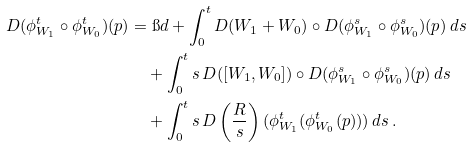<formula> <loc_0><loc_0><loc_500><loc_500>D ( \phi ^ { t } _ { W _ { 1 } } \circ \phi ^ { t } _ { W _ { 0 } } ) ( p ) & = \i d + \int _ { 0 } ^ { t } D ( W _ { 1 } + W _ { 0 } ) \circ D ( \phi ^ { s } _ { W _ { 1 } } \circ \phi ^ { s } _ { W _ { 0 } } ) ( p ) \, d s \\ & \quad + \int _ { 0 } ^ { t } s \, D ( [ W _ { 1 } , W _ { 0 } ] ) \circ D ( \phi ^ { s } _ { W _ { 1 } } \circ \phi ^ { s } _ { W _ { 0 } } ) ( p ) \, d s \\ & \quad + \int _ { 0 } ^ { t } s \, D \left ( \frac { R } { s } \right ) ( \phi ^ { t } _ { W _ { 1 } } ( \phi ^ { t } _ { W _ { 0 } } ( p ) ) ) \, d s \, .</formula> 